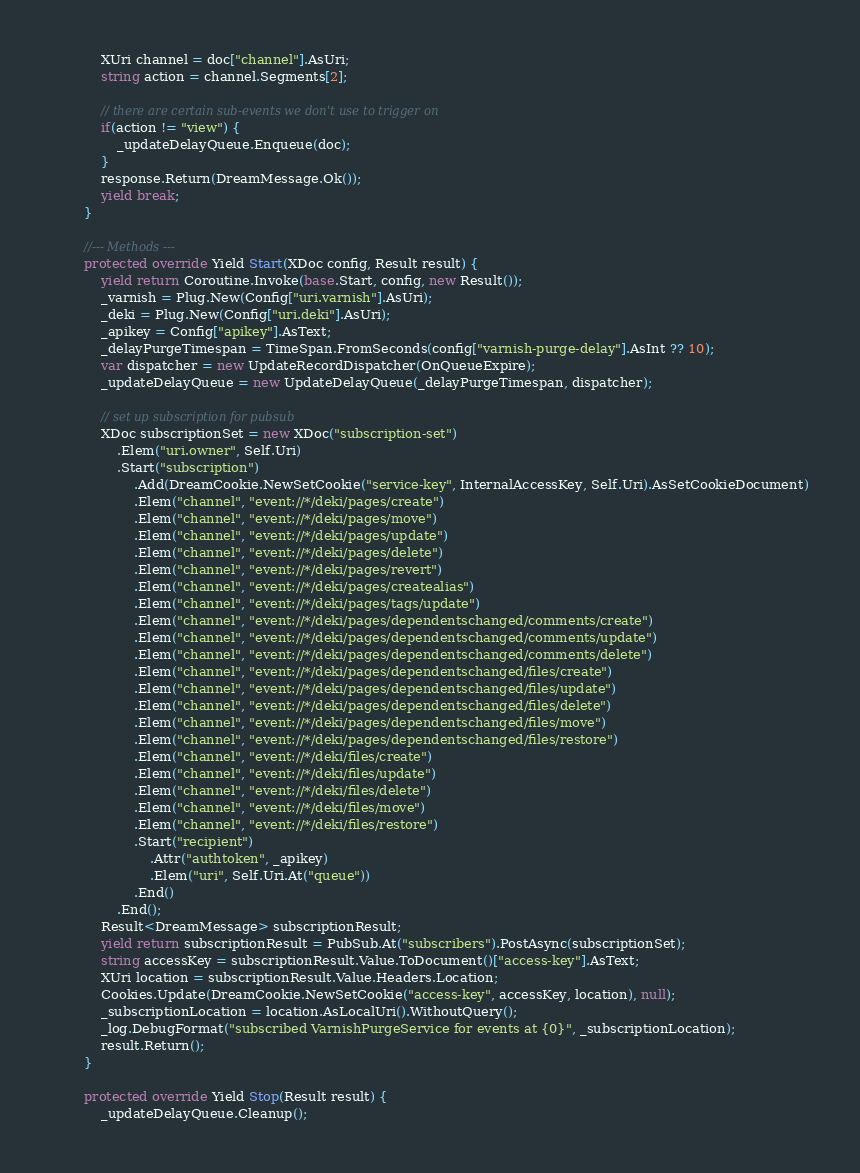Convert code to text. <code><loc_0><loc_0><loc_500><loc_500><_C#_>            XUri channel = doc["channel"].AsUri;
            string action = channel.Segments[2];

            // there are certain sub-events we don't use to trigger on
            if(action != "view") {
                _updateDelayQueue.Enqueue(doc);
            }
            response.Return(DreamMessage.Ok());
            yield break;
        }

        //--- Methods ---
        protected override Yield Start(XDoc config, Result result) {
            yield return Coroutine.Invoke(base.Start, config, new Result());
            _varnish = Plug.New(Config["uri.varnish"].AsUri);
            _deki = Plug.New(Config["uri.deki"].AsUri);
            _apikey = Config["apikey"].AsText;
            _delayPurgeTimespan = TimeSpan.FromSeconds(config["varnish-purge-delay"].AsInt ?? 10);
            var dispatcher = new UpdateRecordDispatcher(OnQueueExpire);
            _updateDelayQueue = new UpdateDelayQueue(_delayPurgeTimespan, dispatcher);

            // set up subscription for pubsub
            XDoc subscriptionSet = new XDoc("subscription-set")
                .Elem("uri.owner", Self.Uri)
                .Start("subscription")
                    .Add(DreamCookie.NewSetCookie("service-key", InternalAccessKey, Self.Uri).AsSetCookieDocument)
                    .Elem("channel", "event://*/deki/pages/create")
                    .Elem("channel", "event://*/deki/pages/move")
                    .Elem("channel", "event://*/deki/pages/update")
                    .Elem("channel", "event://*/deki/pages/delete")
                    .Elem("channel", "event://*/deki/pages/revert")
                    .Elem("channel", "event://*/deki/pages/createalias")
                    .Elem("channel", "event://*/deki/pages/tags/update")
                    .Elem("channel", "event://*/deki/pages/dependentschanged/comments/create")
                    .Elem("channel", "event://*/deki/pages/dependentschanged/comments/update")
                    .Elem("channel", "event://*/deki/pages/dependentschanged/comments/delete")
                    .Elem("channel", "event://*/deki/pages/dependentschanged/files/create")
                    .Elem("channel", "event://*/deki/pages/dependentschanged/files/update")
                    .Elem("channel", "event://*/deki/pages/dependentschanged/files/delete")
                    .Elem("channel", "event://*/deki/pages/dependentschanged/files/move")
                    .Elem("channel", "event://*/deki/pages/dependentschanged/files/restore")
                    .Elem("channel", "event://*/deki/files/create")
                    .Elem("channel", "event://*/deki/files/update")
                    .Elem("channel", "event://*/deki/files/delete")
                    .Elem("channel", "event://*/deki/files/move")
                    .Elem("channel", "event://*/deki/files/restore")
                    .Start("recipient")
                        .Attr("authtoken", _apikey)
                        .Elem("uri", Self.Uri.At("queue"))
                    .End()
                .End();
            Result<DreamMessage> subscriptionResult;
            yield return subscriptionResult = PubSub.At("subscribers").PostAsync(subscriptionSet);
            string accessKey = subscriptionResult.Value.ToDocument()["access-key"].AsText;
            XUri location = subscriptionResult.Value.Headers.Location;
            Cookies.Update(DreamCookie.NewSetCookie("access-key", accessKey, location), null);
            _subscriptionLocation = location.AsLocalUri().WithoutQuery();
            _log.DebugFormat("subscribed VarnishPurgeService for events at {0}", _subscriptionLocation);
            result.Return();
        }

        protected override Yield Stop(Result result) {
            _updateDelayQueue.Cleanup();</code> 